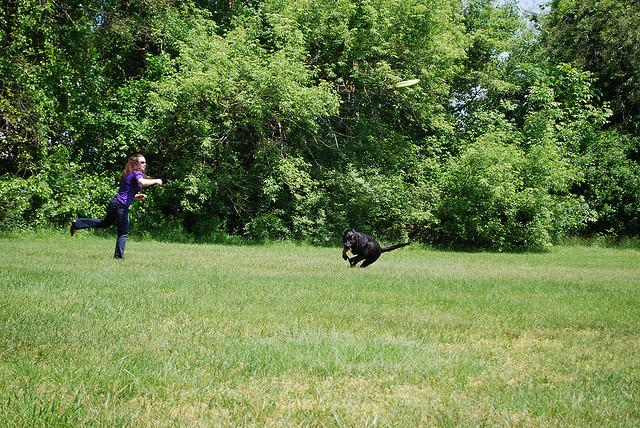What is the woman most likely to be most days of the week? Please explain your reasoning. animal lover. The woman on the left has a dog she plays with which makes her an animal lover. 